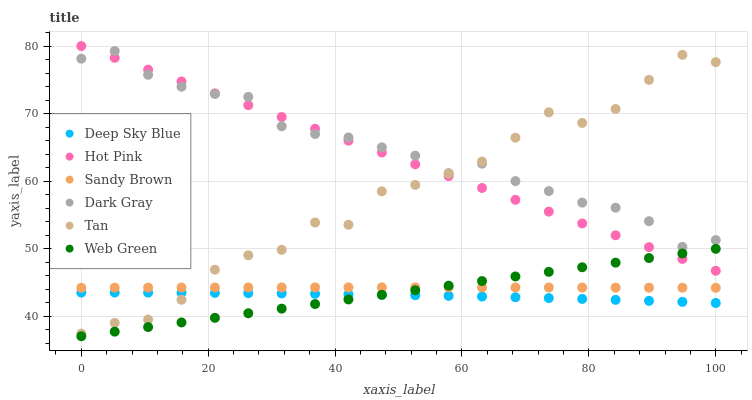Does Deep Sky Blue have the minimum area under the curve?
Answer yes or no. Yes. Does Dark Gray have the maximum area under the curve?
Answer yes or no. Yes. Does Web Green have the minimum area under the curve?
Answer yes or no. No. Does Web Green have the maximum area under the curve?
Answer yes or no. No. Is Web Green the smoothest?
Answer yes or no. Yes. Is Tan the roughest?
Answer yes or no. Yes. Is Dark Gray the smoothest?
Answer yes or no. No. Is Dark Gray the roughest?
Answer yes or no. No. Does Web Green have the lowest value?
Answer yes or no. Yes. Does Dark Gray have the lowest value?
Answer yes or no. No. Does Hot Pink have the highest value?
Answer yes or no. Yes. Does Web Green have the highest value?
Answer yes or no. No. Is Sandy Brown less than Dark Gray?
Answer yes or no. Yes. Is Sandy Brown greater than Deep Sky Blue?
Answer yes or no. Yes. Does Tan intersect Deep Sky Blue?
Answer yes or no. Yes. Is Tan less than Deep Sky Blue?
Answer yes or no. No. Is Tan greater than Deep Sky Blue?
Answer yes or no. No. Does Sandy Brown intersect Dark Gray?
Answer yes or no. No. 